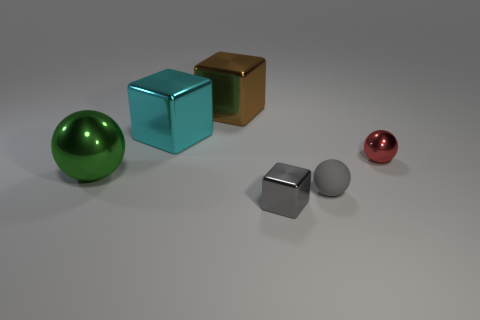What is the texture of the objects in the center? The objects in the center, a cube and a sphere, exhibit a matte texture with a solid color finish, lacking reflective properties. 